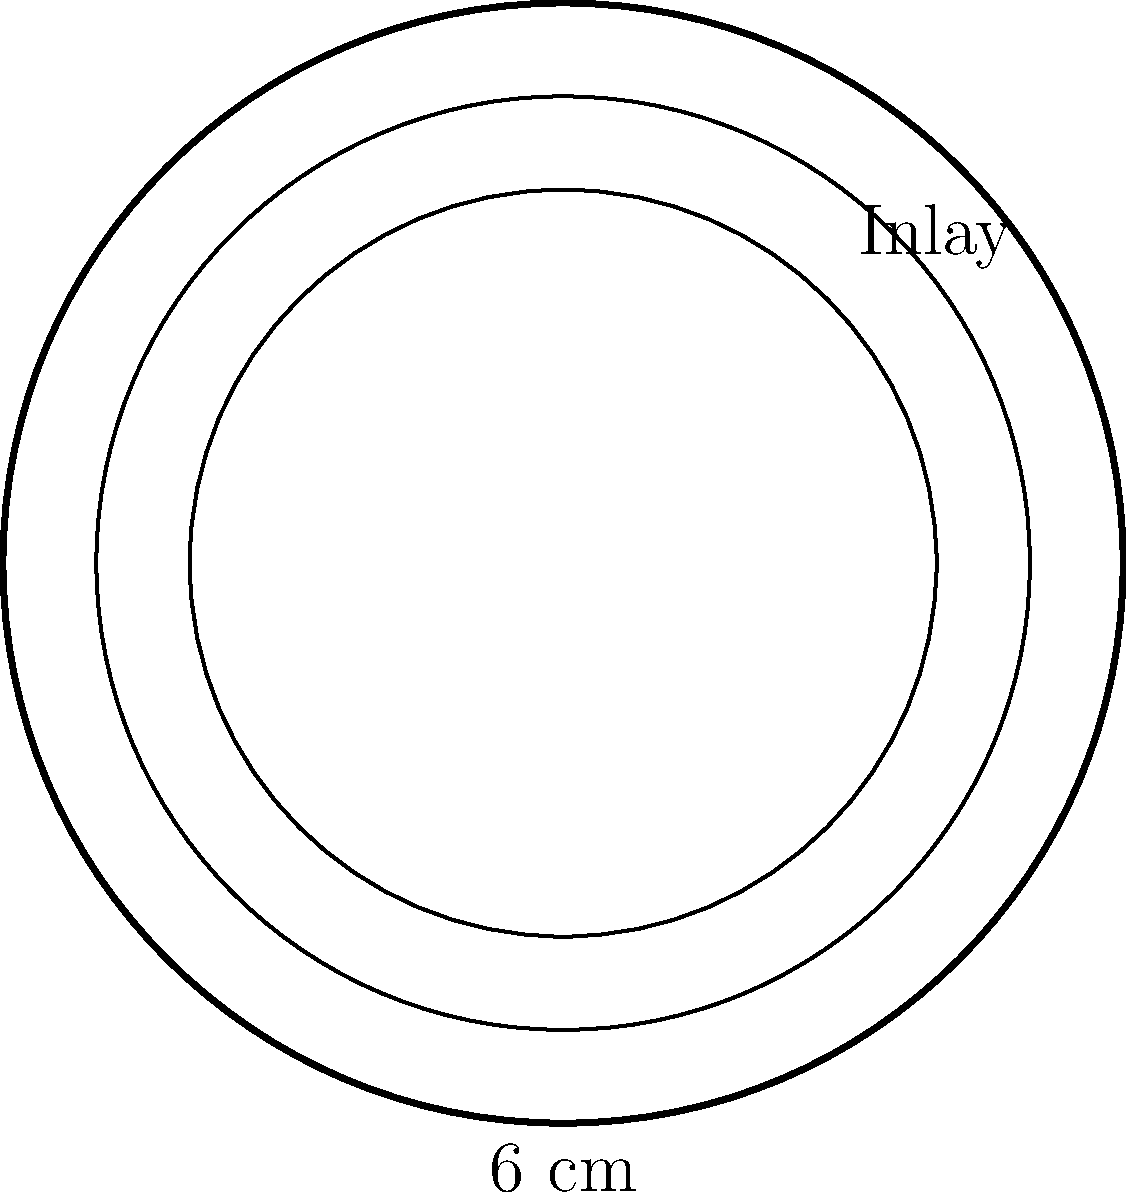You've discovered a beautiful antique circular tabletop with intricate inlaid wood designs. The tabletop has a diameter of 6 cm and features two concentric circular inlays, each 0.5 cm wide. Calculate the total area of the tabletop that is not covered by the inlaid designs. To solve this problem, we'll follow these steps:

1) First, calculate the radius of the tabletop:
   Diameter = 6 cm, so radius $r = 6/2 = 3$ cm

2) Calculate the area of the entire tabletop:
   $A_{total} = \pi r^2 = \pi (3^2) = 9\pi$ cm²

3) Calculate the radius of the outer edge of the first inlay:
   $r_1 = 3 - 0.5 = 2.5$ cm

4) Calculate the radius of the outer edge of the second inlay:
   $r_2 = 3 - 0.5 - 0.5 = 2$ cm

5) Calculate the areas of the circles formed by these radii:
   $A_1 = \pi (2.5^2) = 6.25\pi$ cm²
   $A_2 = \pi (2^2) = 4\pi$ cm²

6) The area not covered by inlays is the area of the innermost circle plus the area between the inlays:
   $A_{not covered} = A_2 + (A_{total} - A_1)$
   $A_{not covered} = 4\pi + (9\pi - 6.25\pi)$
   $A_{not covered} = 4\pi + 2.75\pi = 6.75\pi$ cm²

Therefore, the area of the tabletop not covered by inlaid designs is $6.75\pi$ cm².
Answer: $6.75\pi$ cm² 